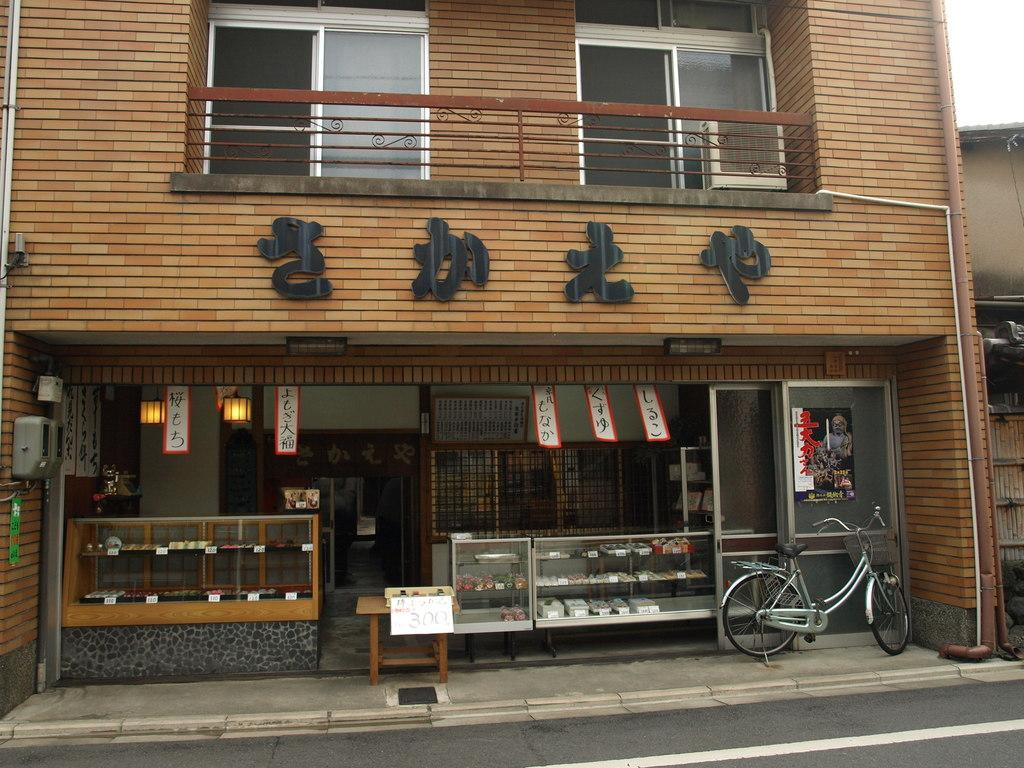What type of structure is present in the image? There is a building in the image. What feature can be seen on the building? The building has windows. What mode of transportation is visible in the image? There is a bicycle in the image. What type of surface is present in the image? There is a road in the image. What type of record can be seen playing in the background of the image? There is no record player or record visible in the image. 